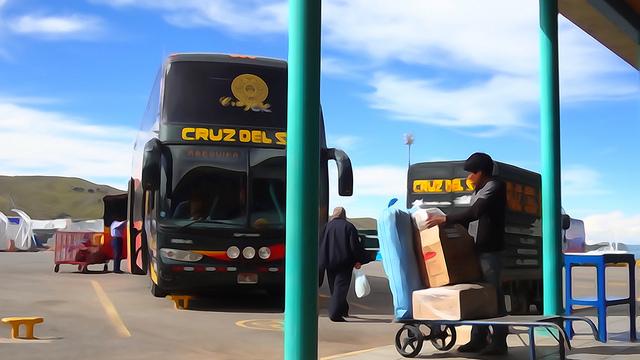How many buses are here?
Give a very brief answer. 2. What color is the lettering on the trucks?
Give a very brief answer. Yellow. What language is on the bus?
Concise answer only. Spanish. 